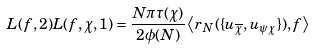<formula> <loc_0><loc_0><loc_500><loc_500>L ( f , 2 ) L ( f , \chi , 1 ) = \frac { N \pi \tau ( \chi ) } { 2 \phi ( N ) } \left \langle r _ { N } ( \{ u _ { \overline { \chi } } , u _ { \psi \chi } \} ) , f \right \rangle</formula> 